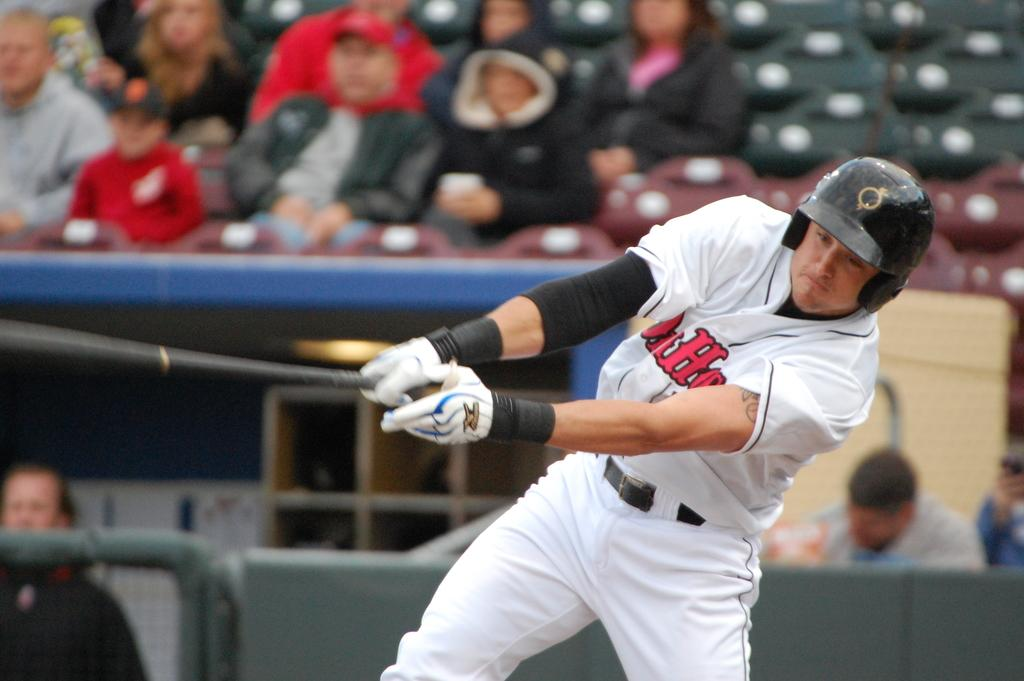Provide a one-sentence caption for the provided image. the batter wears a jersey with a capital letter H in the front middle. 